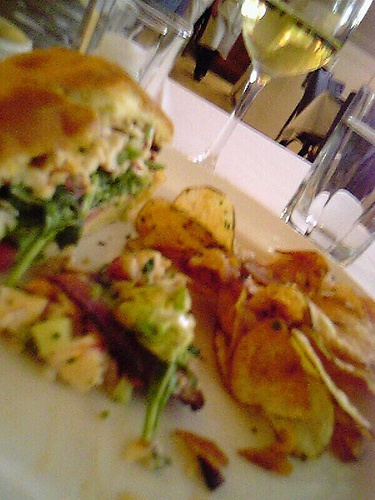Describe the objects in this image and their specific colors. I can see dining table in tan, olive, maroon, and black tones, sandwich in black, olive, tan, and maroon tones, wine glass in black, olive, lightgray, and tan tones, cup in black, gray, lightgray, darkgray, and purple tones, and cup in black, darkgray, and gray tones in this image. 